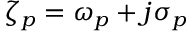Convert formula to latex. <formula><loc_0><loc_0><loc_500><loc_500>\zeta _ { p } = \omega _ { p } + j \sigma _ { p }</formula> 